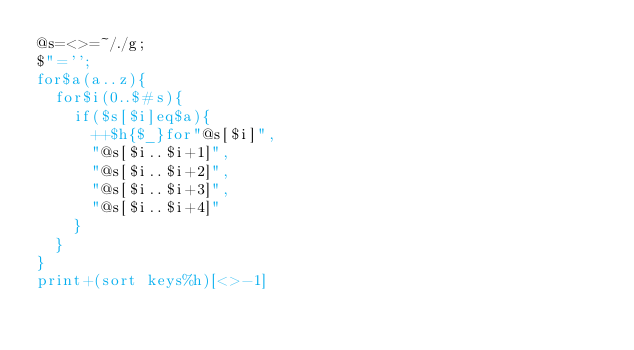<code> <loc_0><loc_0><loc_500><loc_500><_Perl_>@s=<>=~/./g;
$"='';
for$a(a..z){
	for$i(0..$#s){
		if($s[$i]eq$a){
			++$h{$_}for"@s[$i]",
			"@s[$i..$i+1]",
			"@s[$i..$i+2]",
			"@s[$i..$i+3]",
			"@s[$i..$i+4]"
		}
	}
}
print+(sort keys%h)[<>-1]
</code> 